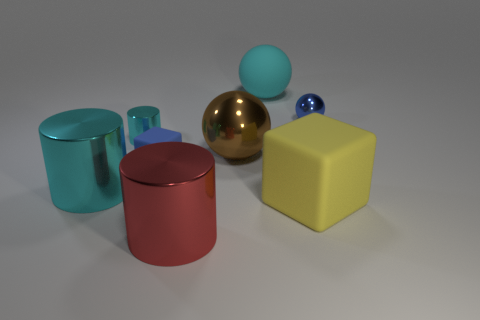Can you describe the shapes and their arrangement in the image? Certainly! The image features a variety of geometric shapes precisely arranged on a flat surface. From left to right, there's a cyan cylinder, a red cylinder, a shiny brass-colored sphere, a smaller blue sphere, and a large yellow cube. The forms are evenly spaced, suggesting a deliberate effort to create a balanced composition that highlights each shape's distinct contours and color.  What kind of mood or theme could this selection and arrangement of objects convey? The clean lines, simple geometric forms, and the bright, primary color palette could convey a theme of clarity, simplicity, and playfulness. It might suggest a modern or minimalist aesthetic. The purposeful arrangement and pristine condition of the objects could evoke a sense of order and harmony. It's reminiscent of a child's building blocks, inviting one to think about the fundamentals of design and color theory. 